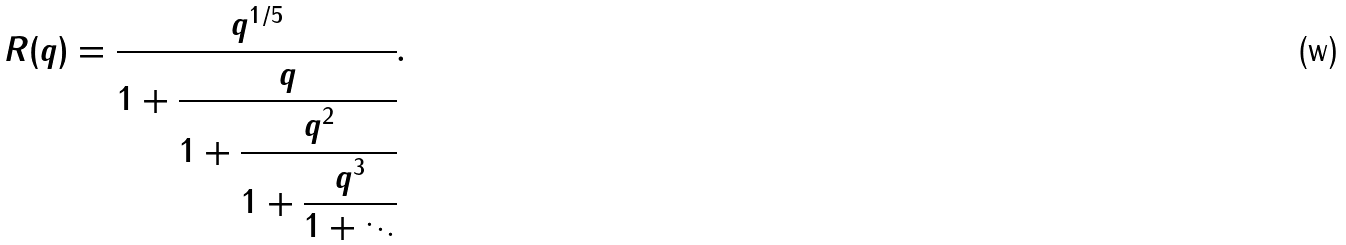<formula> <loc_0><loc_0><loc_500><loc_500>R ( q ) = { \cfrac { q ^ { 1 / 5 } } { 1 + { \cfrac { q } { 1 + { \cfrac { q ^ { 2 } } { 1 + { \cfrac { q ^ { 3 } } { 1 + \ddots } } } } } } } } .</formula> 